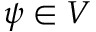<formula> <loc_0><loc_0><loc_500><loc_500>\psi \in V</formula> 